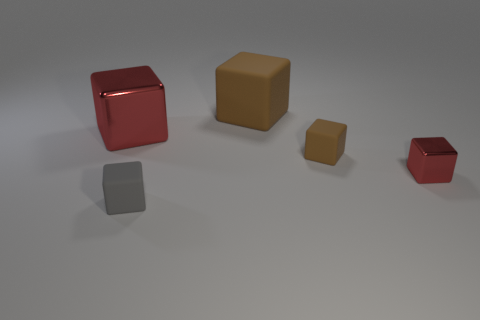Subtract all large brown cubes. How many cubes are left? 4 Subtract all gray cylinders. How many brown blocks are left? 2 Subtract all gray blocks. How many blocks are left? 4 Add 3 tiny shiny cubes. How many objects exist? 8 Subtract 3 cubes. How many cubes are left? 2 Subtract all blue blocks. Subtract all purple cylinders. How many blocks are left? 5 Subtract all small metal objects. Subtract all big red metallic cubes. How many objects are left? 3 Add 4 tiny metallic blocks. How many tiny metallic blocks are left? 5 Add 2 brown rubber cubes. How many brown rubber cubes exist? 4 Subtract 1 gray blocks. How many objects are left? 4 